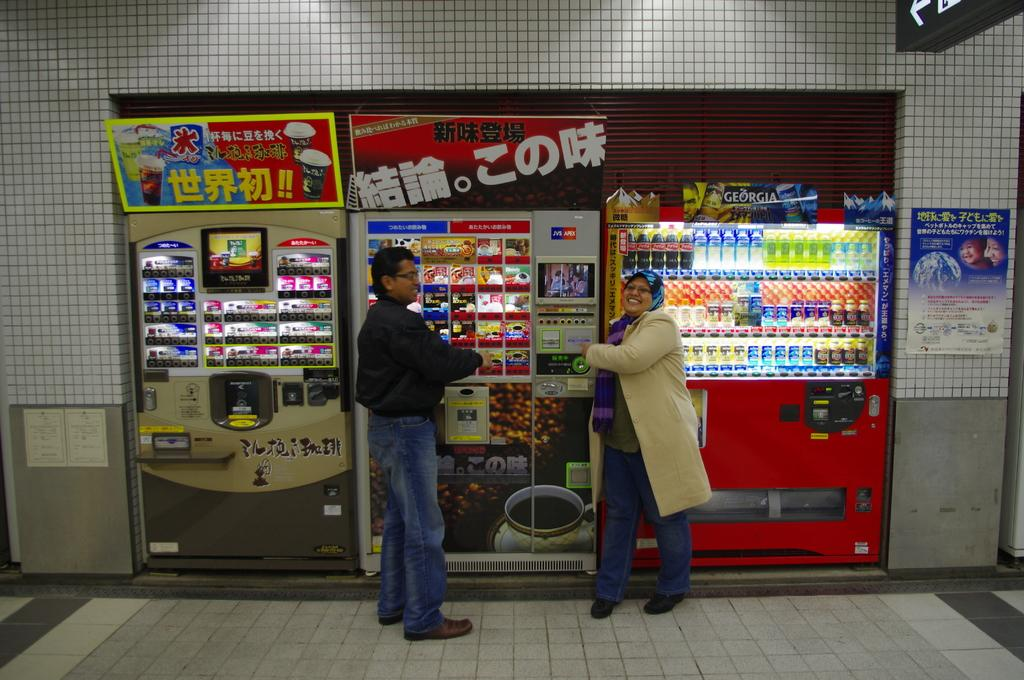How many people are in the image? There are two people in the image, a man and a woman. What are the man and woman wearing? The man and woman are wearing clothes, shoes, and spectacles. What can be seen in the image besides the man and woman? There are food items, a machine, the floor, and a poster visible in the image. What type of cable can be seen connecting the man and woman in the image? There is no cable connecting the man and woman in the image. 